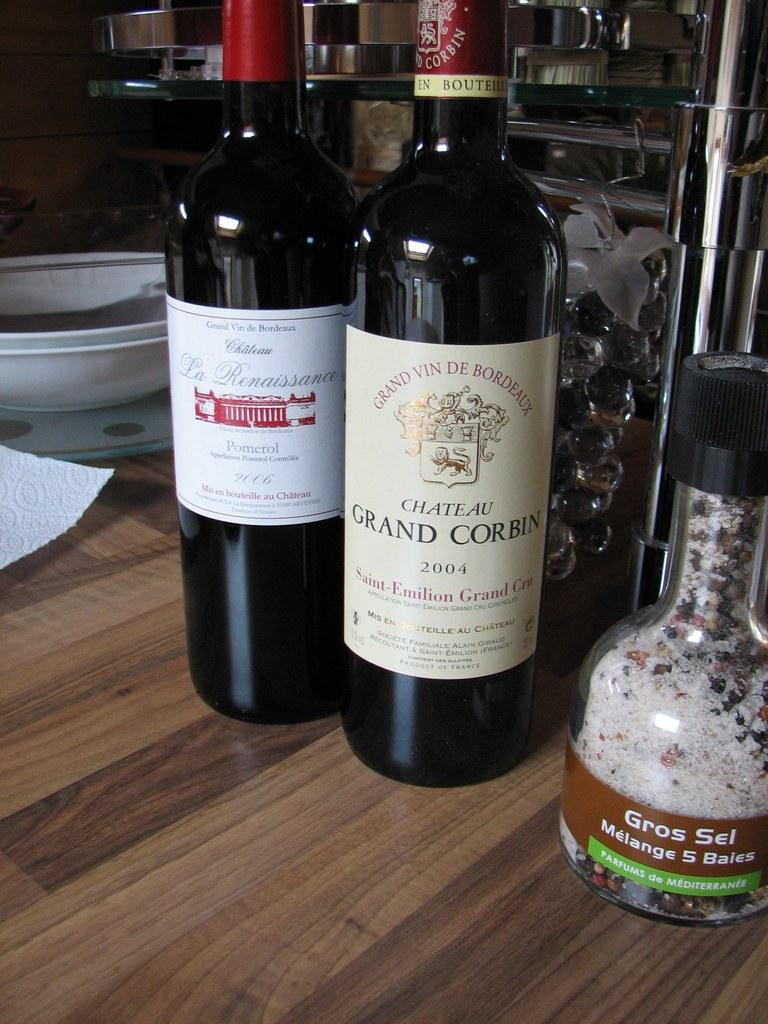<image>
Offer a succinct explanation of the picture presented. Two red wine bottles are on a table and one was bottle in 2004. 